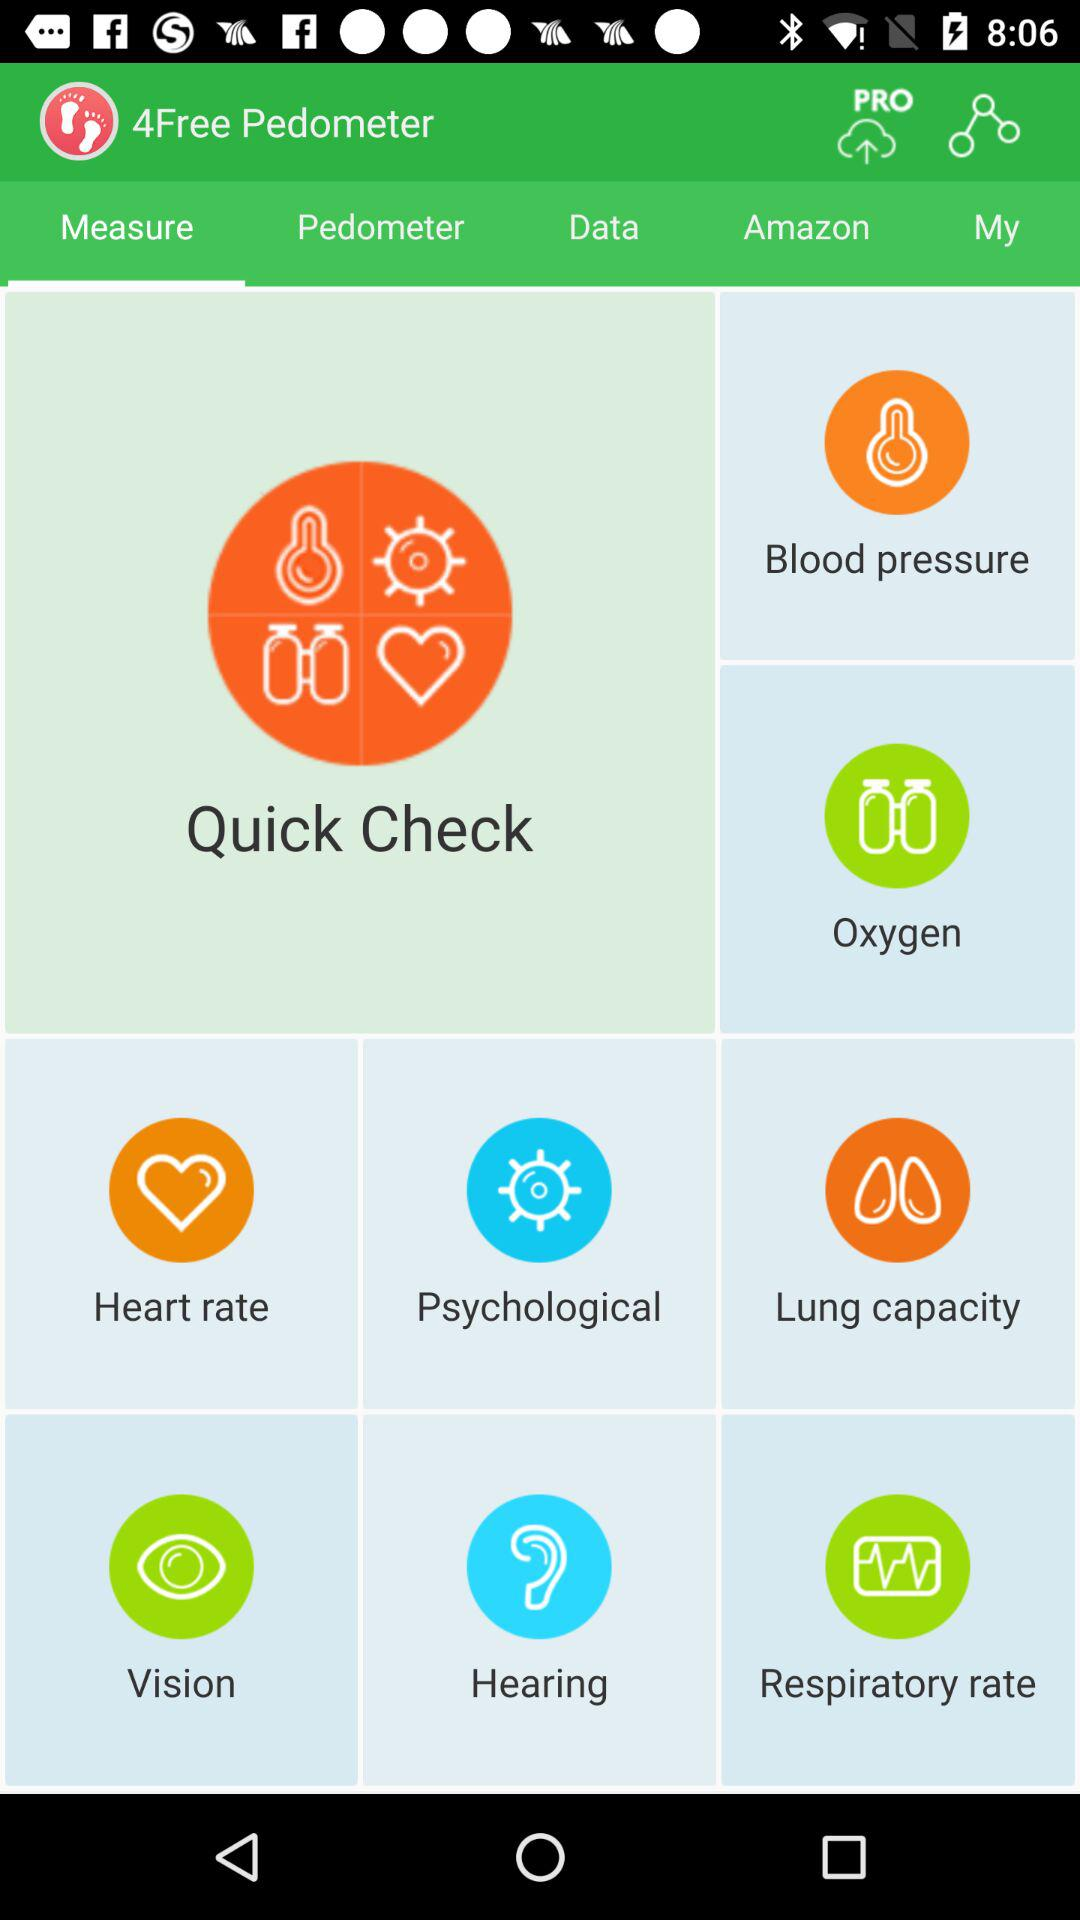How high is the blood pressure?
When the provided information is insufficient, respond with <no answer>. <no answer> 